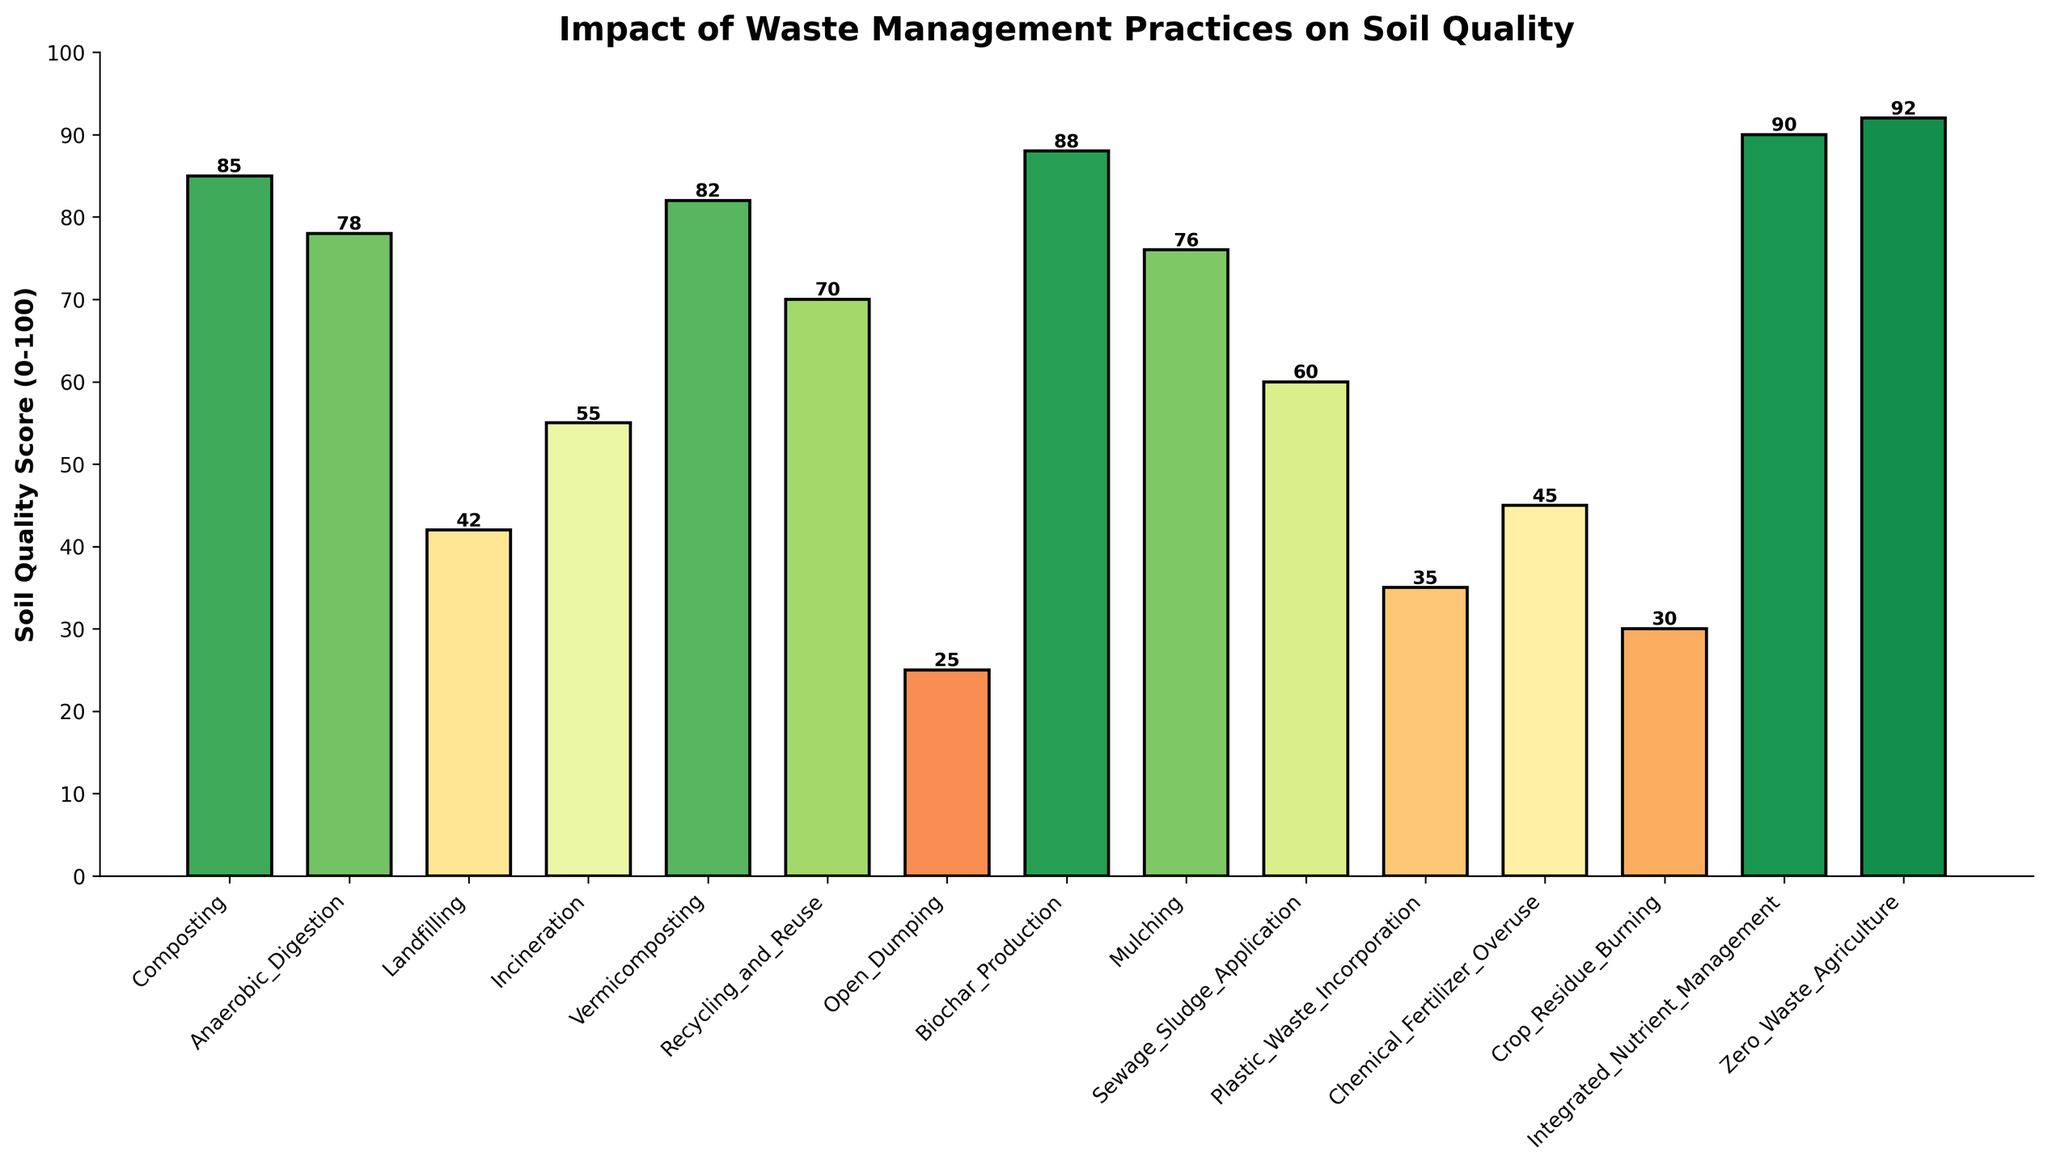Which waste management practice has the highest soil quality score? The figure shows bars representing different waste management practices and their associated soil quality scores. The highest soil quality score is represented by the tallest bar.
Answer: Zero Waste Agriculture How much higher is the soil quality score of Composting compared to Plastic Waste Incorporation? To determine this, locate the bars for Composting and Plastic Waste Incorporation and subtract the score of Plastic Waste Incorporation from that of Composting. Composting has a score of 85, and Plastic Waste Incorporation has 35, so 85 - 35 = 50.
Answer: 50 What is the average soil quality score among the practices with scores above 80? Look at the bars above the score of 80. These are Biochar Production (88), Integrated Nutrient Management (90), Zero Waste Agriculture (92), Vermicomposting (82), and Composting (85). Sum these scores and divide by the number of practices: (88 + 90 + 92 + 82 + 85) / 5 = 437 / 5 = 87.4.
Answer: 87.4 Which practices have a soil quality score below 50, and what are their scores? The bars below the score of 50 are Landfilling (42), Open Dumping (25), Plastic Waste Incorporation (35), Chemical Fertilizer Overuse (45), and Crop Residue Burning (30).
Answer: Landfilling (42), Open Dumping (25), Plastic Waste Incorporation (35), Chemical Fertilizer Overuse (45), Crop Residue Burning (30) Is the soil quality score higher for Anaerobic Digestion or for Mulching? Locate the bars for Anaerobic Digestion and Mulching and compare their heights. Anaerobic Digestion has a score of 78, while Mulching has a score of 76.
Answer: Anaerobic Digestion What is the difference in soil quality scores between the highest scoring and lowest scoring waste management practices? Identify the highest and lowest scores from the bars—Zero Waste Agriculture (92) for the highest and Open Dumping (25) for the lowest. Calculate the difference: 92 - 25 = 67.
Answer: 67 How many waste management practices have a soil quality score of 60 or higher? Count the number of bars with heights corresponding to scores of 60 or above. They are Composting, Anaerobic Digestion, Vermicomposting, Recycling and Reuse, Biochar Production, Mulching, Sewage Sludge Application, Integrated Nutrient Management, and Zero Waste Agriculture—9 practices in total.
Answer: 9 Which color visually represents the best practices for soil quality? Visually identify the color gradient used in the figure. The bars with the highest scores (85 and above) are colored in the upper spectrum of the color palette (darker shades).
Answer: Dark green Compared to Incineration, how does Recycling and Reuse affect soil quality? Locate the bars for Incineration (55) and Recycling and Reuse (70) and compare their heights. Recycling and Reuse has a higher soil quality score than Incineration.
Answer: Recycling and Reuse has a higher soil quality score 